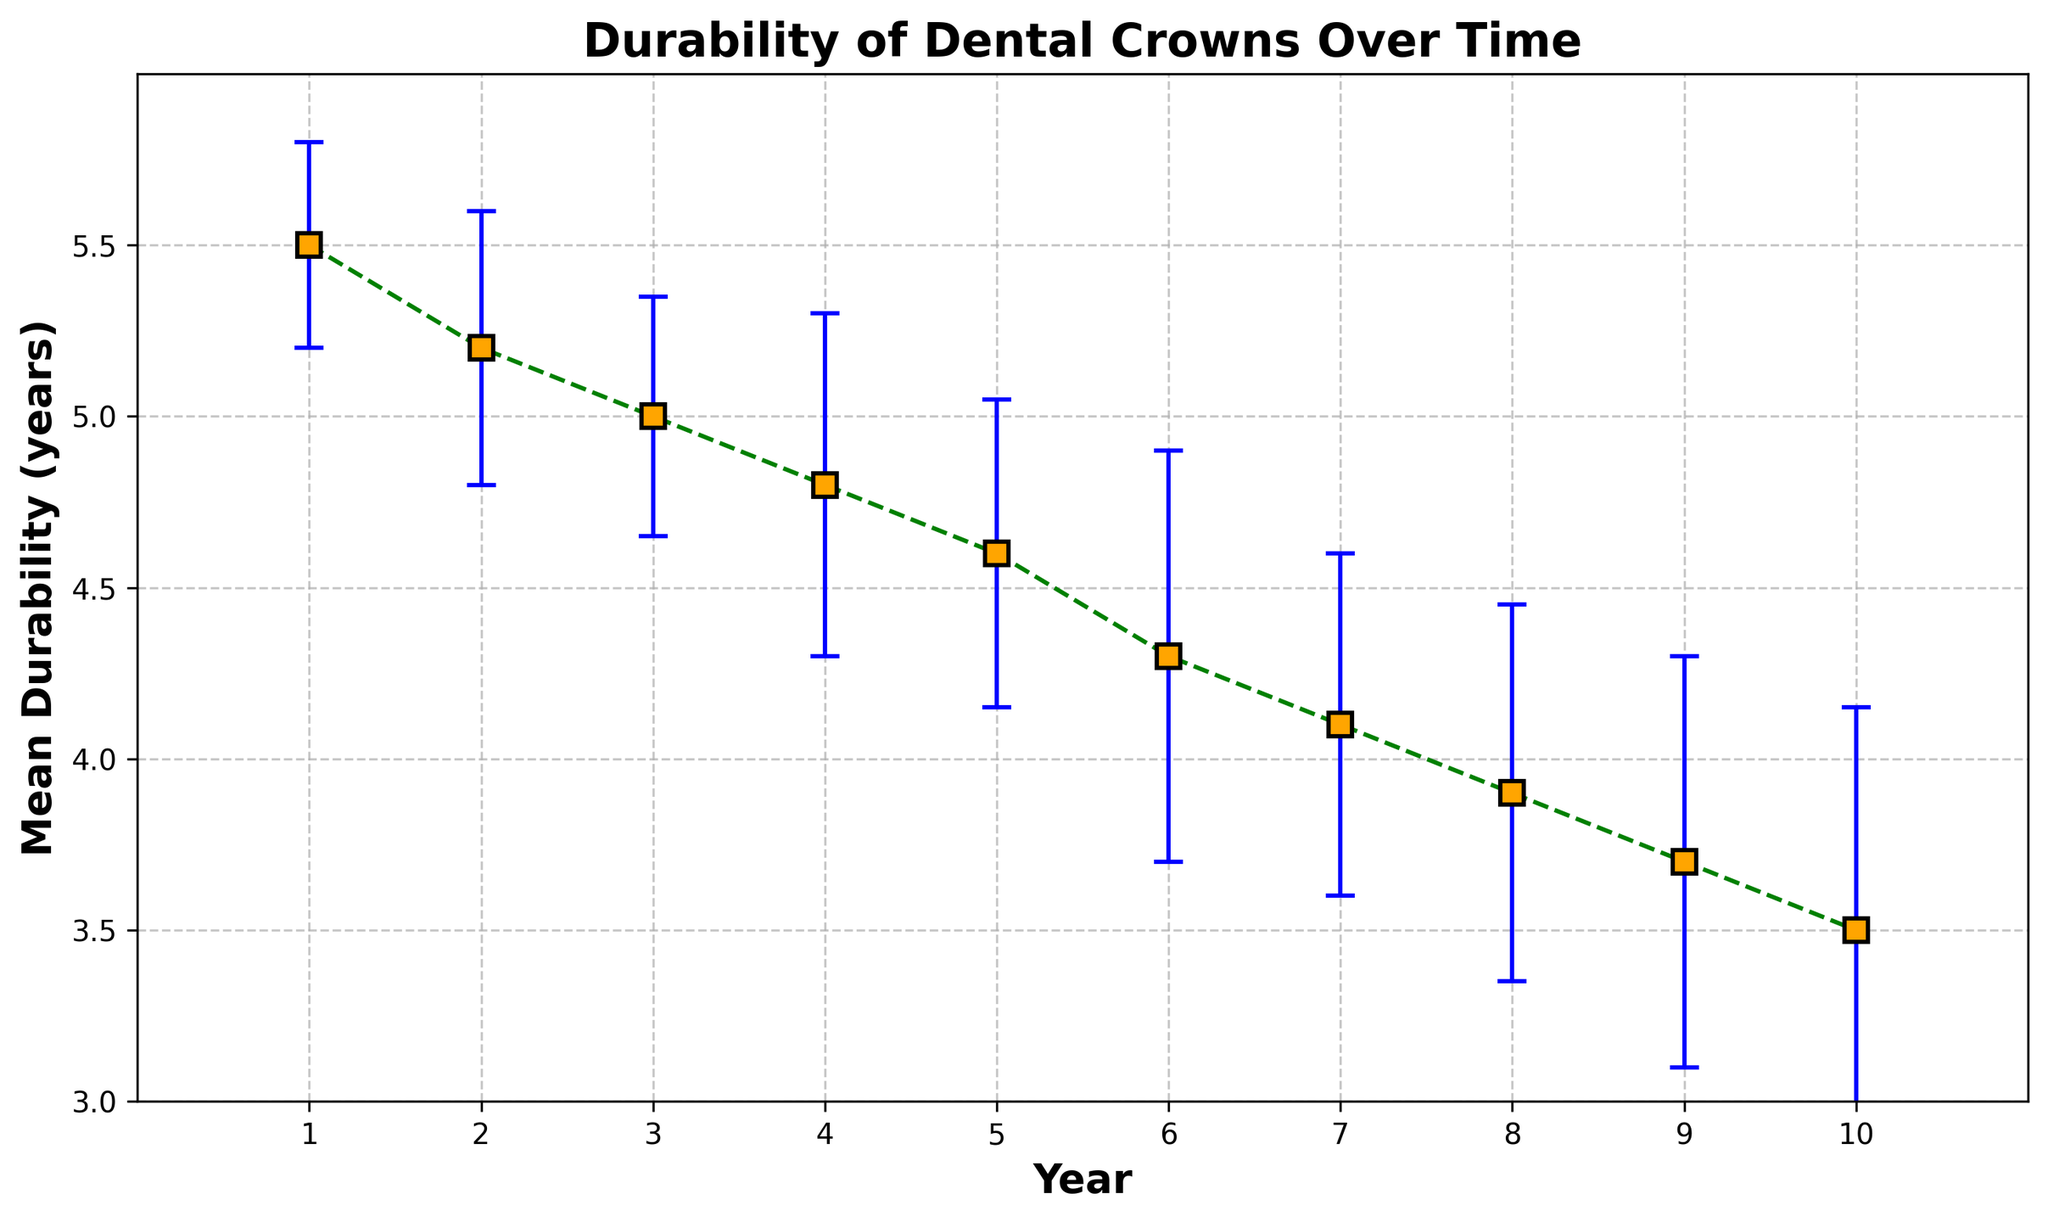1. What is the mean durability of dental crowns in year 5? According to the figure, the mean durability value for year 5 is marked at 4.6 years, as shown by the corresponding data point on the plot.
Answer: 4.6 years 2. How does the mean durability of dental crowns change from year 1 to year 10? From the figure, the mean durability decreases from year 1 to year 10. The mean durability starts at 5.5 years and decreases to 3.5 years.
Answer: Decreases 3. Which year has the highest mean durability? The highest mean durability is identified by finding the tallest data point on the plot, which corresponds to year 1 with a mean durability of 5.5 years.
Answer: Year 1 4. What is the difference in mean durability between years 2 and 7? The mean durability for year 2 is 5.2 years and for year 7 is 4.1 years. The difference is 5.2 - 4.1 = 1.1 years.
Answer: 1.1 years 5. Which year shows the largest standard error in the durability estimate? The largest standard error corresponds to the point with the longest error bar. For year 10, the standard error is 0.65 years, which is the highest in the dataset.
Answer: Year 10 6. By how much does the mean durability decrease from year 4 to year 8? The mean durability for year 4 is 4.8 years and for year 8 is 3.9 years. The decrease is calculated as 4.8 - 3.9 = 0.9 years.
Answer: 0.9 years 7. Which two consecutive years have the smallest difference in mean durability? Checking the differences between consecutive years, years 2 to 3 and 5 to 6 both show a difference of 0.2 years.
Answer: Years 5 to 6 8. Are there any years where the error bars overlap with adjacent years? YES, there are years with overlapping error bars, such as between years 6 and 7, suggesting that their mean durability estimates are not significantly different.
Answer: Yes 9. What pattern do you observe in the mean durability over the 10 years? The pattern shows a general decreasing trend in mean durability over the 10 years, indicating that the durability of dental crowns diminishes over time.
Answer: Decreasing trend 10. If you combine the mean durability values from years 1 and 2, what is the result? The result is obtained by summing the mean durability of years 1 and 2, which are 5.5 and 5.2 respectively. 5.5 + 5.2 = 10.7 years.
Answer: 10.7 years 